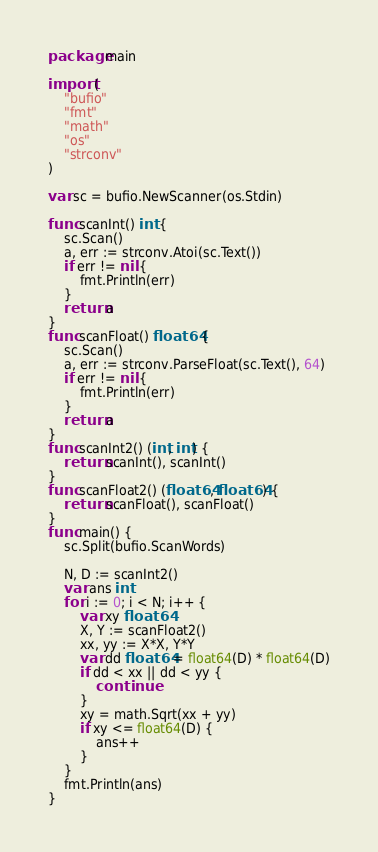<code> <loc_0><loc_0><loc_500><loc_500><_Go_>package main

import (
	"bufio"
	"fmt"
	"math"
	"os"
	"strconv"
)

var sc = bufio.NewScanner(os.Stdin)

func scanInt() int {
	sc.Scan()
	a, err := strconv.Atoi(sc.Text())
	if err != nil {
		fmt.Println(err)
	}
	return a
}
func scanFloat() float64 {
	sc.Scan()
	a, err := strconv.ParseFloat(sc.Text(), 64)
	if err != nil {
		fmt.Println(err)
	}
	return a
}
func scanInt2() (int, int) {
	return scanInt(), scanInt()
}
func scanFloat2() (float64, float64) {
	return scanFloat(), scanFloat()
}
func main() {
	sc.Split(bufio.ScanWords)

	N, D := scanInt2()
	var ans int
	for i := 0; i < N; i++ {
		var xy float64
		X, Y := scanFloat2()
		xx, yy := X*X, Y*Y
		var dd float64 = float64(D) * float64(D)
		if dd < xx || dd < yy {
			continue
		}
		xy = math.Sqrt(xx + yy)
		if xy <= float64(D) {
			ans++
		}
	}
	fmt.Println(ans)
}
</code> 